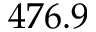Convert formula to latex. <formula><loc_0><loc_0><loc_500><loc_500>4 7 6 . 9</formula> 